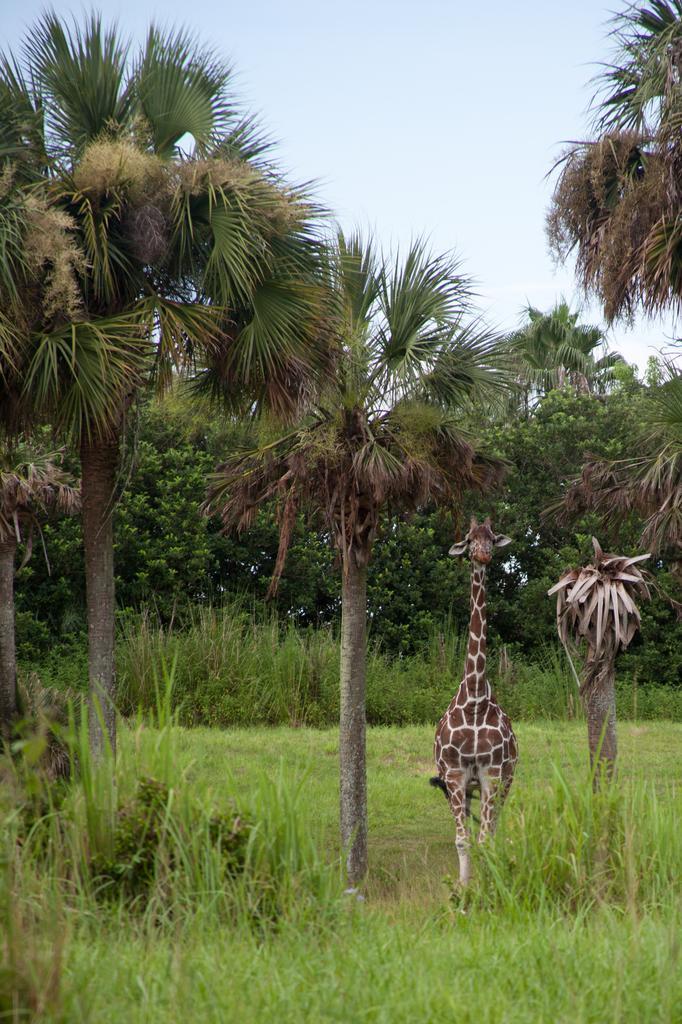In one or two sentences, can you explain what this image depicts? In this picture we can see some grass on the ground. We can see a giraffe, plants, trees and the sky. 